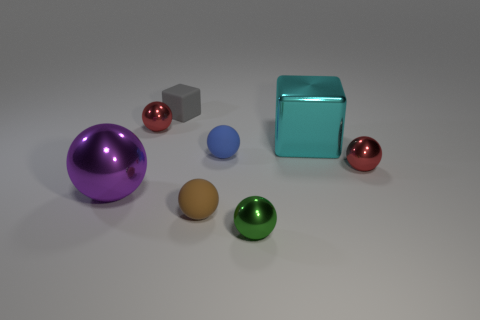Subtract all blue cubes. How many red balls are left? 2 Subtract all tiny green shiny balls. How many balls are left? 5 Subtract all brown balls. How many balls are left? 5 Add 1 big gray balls. How many objects exist? 9 Subtract all brown balls. Subtract all green cubes. How many balls are left? 5 Subtract all balls. How many objects are left? 2 Add 6 cyan cubes. How many cyan cubes are left? 7 Add 1 gray rubber blocks. How many gray rubber blocks exist? 2 Subtract 0 cyan spheres. How many objects are left? 8 Subtract all blue blocks. Subtract all blocks. How many objects are left? 6 